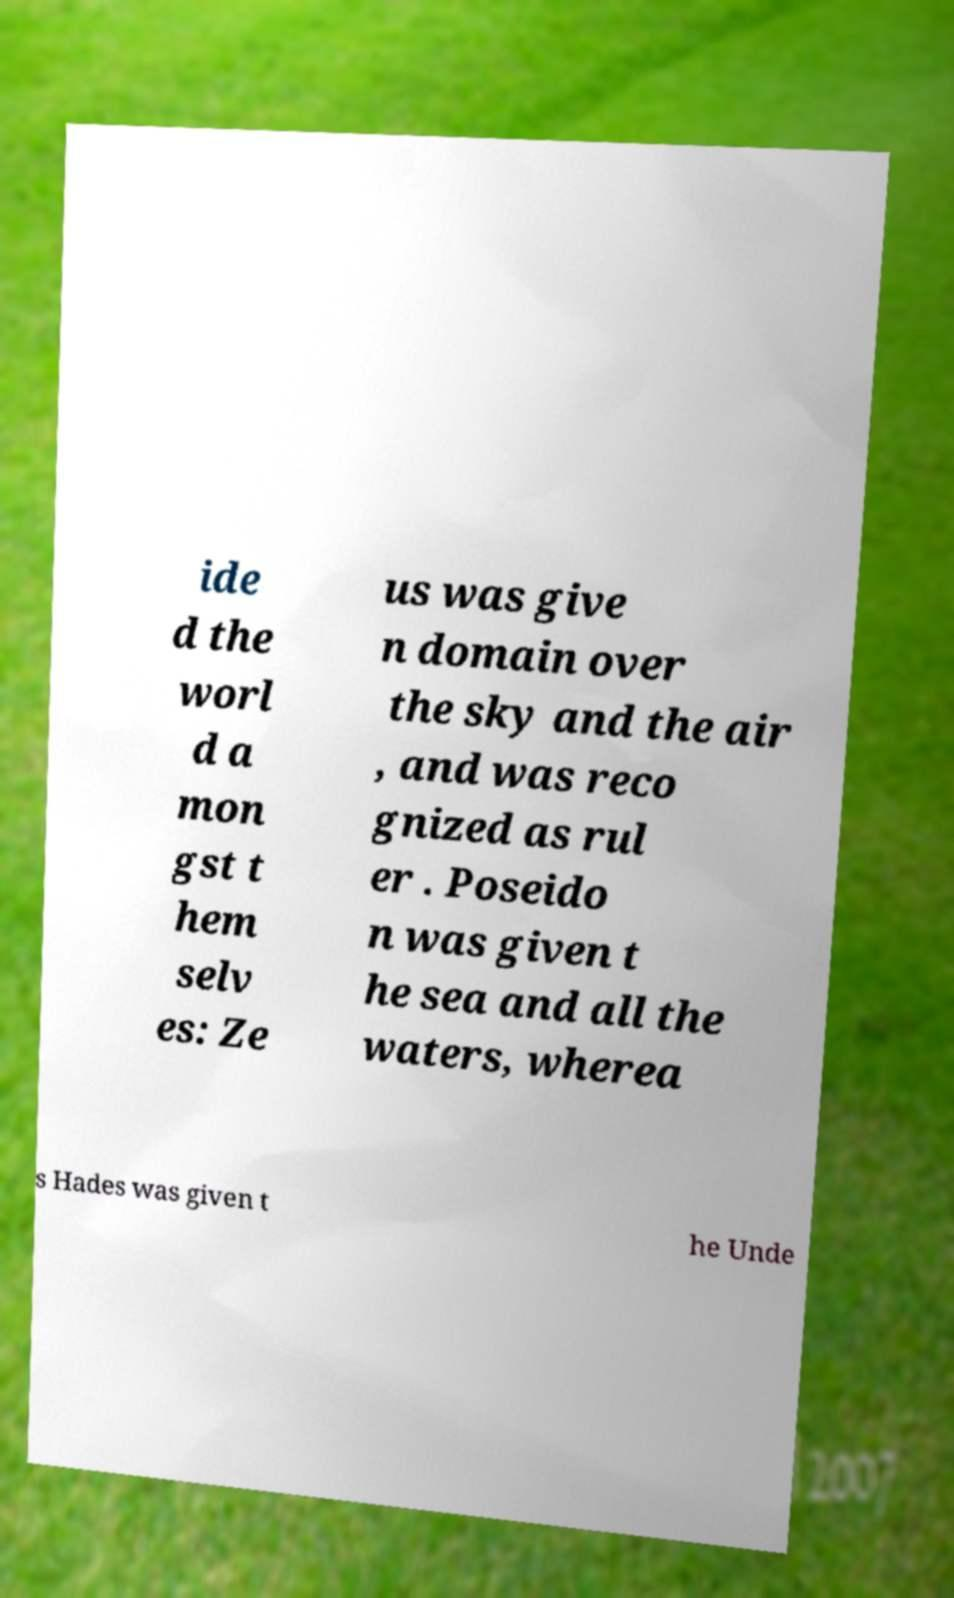Please read and relay the text visible in this image. What does it say? ide d the worl d a mon gst t hem selv es: Ze us was give n domain over the sky and the air , and was reco gnized as rul er . Poseido n was given t he sea and all the waters, wherea s Hades was given t he Unde 